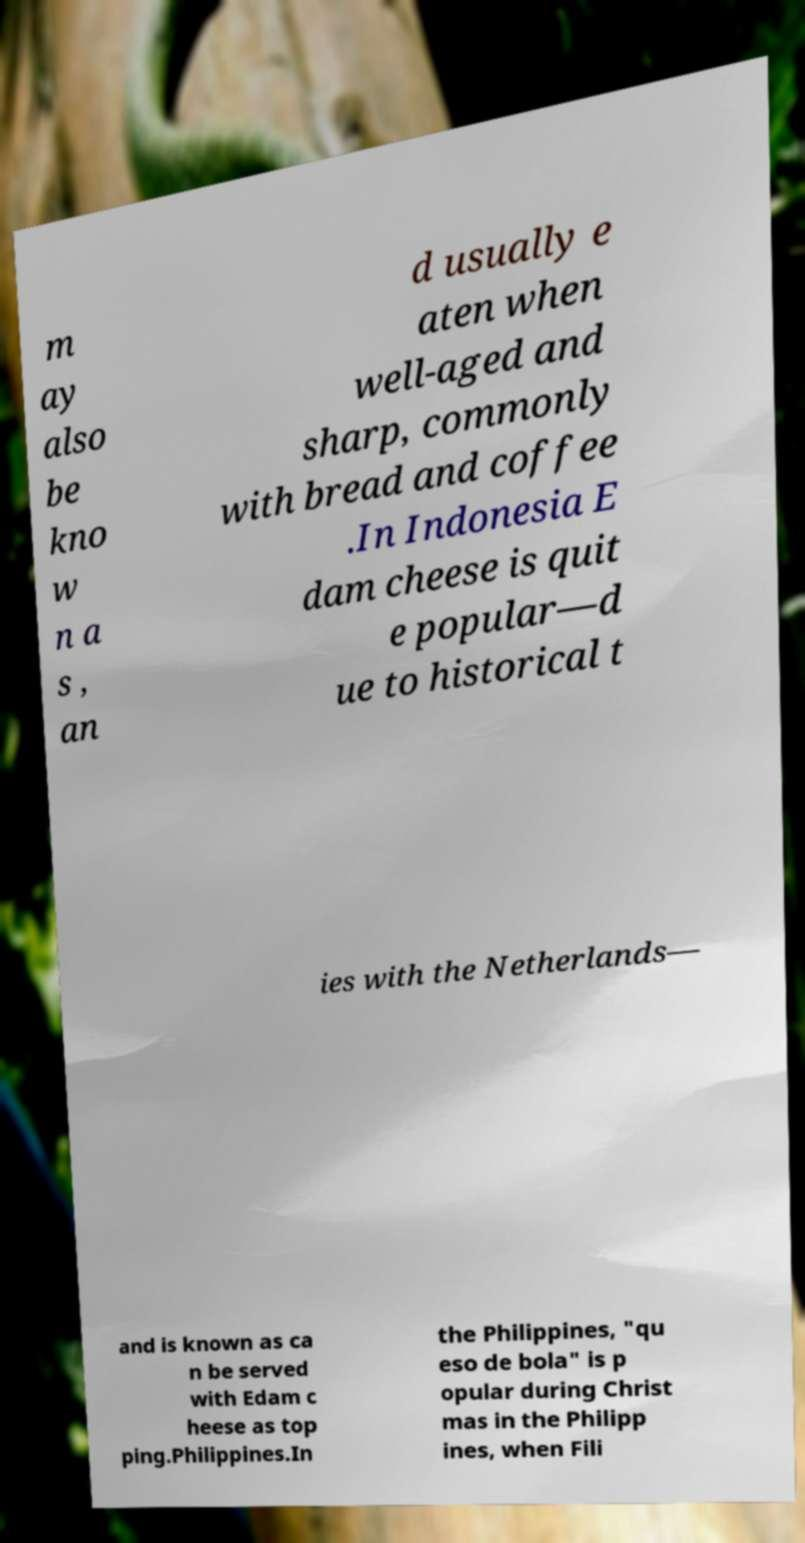Can you read and provide the text displayed in the image?This photo seems to have some interesting text. Can you extract and type it out for me? m ay also be kno w n a s , an d usually e aten when well-aged and sharp, commonly with bread and coffee .In Indonesia E dam cheese is quit e popular—d ue to historical t ies with the Netherlands— and is known as ca n be served with Edam c heese as top ping.Philippines.In the Philippines, "qu eso de bola" is p opular during Christ mas in the Philipp ines, when Fili 